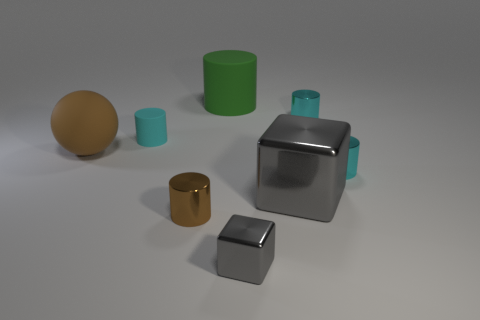Subtract all purple balls. How many cyan cylinders are left? 3 Subtract all red cylinders. Subtract all red blocks. How many cylinders are left? 5 Add 1 tiny brown shiny objects. How many objects exist? 9 Subtract all spheres. How many objects are left? 7 Subtract 0 brown blocks. How many objects are left? 8 Subtract all small cyan rubber cylinders. Subtract all big gray cubes. How many objects are left? 6 Add 6 matte things. How many matte things are left? 9 Add 7 brown metallic cylinders. How many brown metallic cylinders exist? 8 